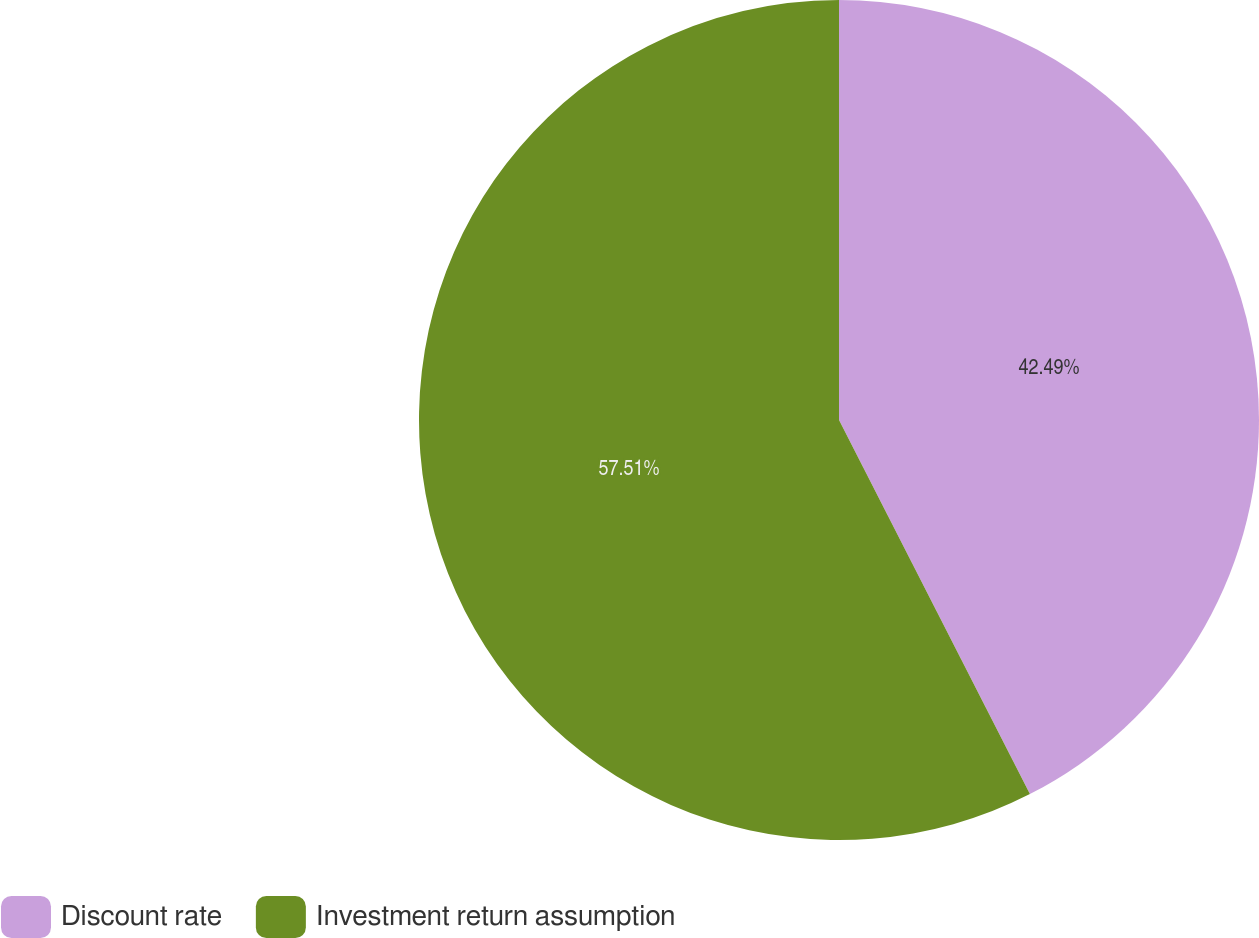Convert chart to OTSL. <chart><loc_0><loc_0><loc_500><loc_500><pie_chart><fcel>Discount rate<fcel>Investment return assumption<nl><fcel>42.49%<fcel>57.51%<nl></chart> 